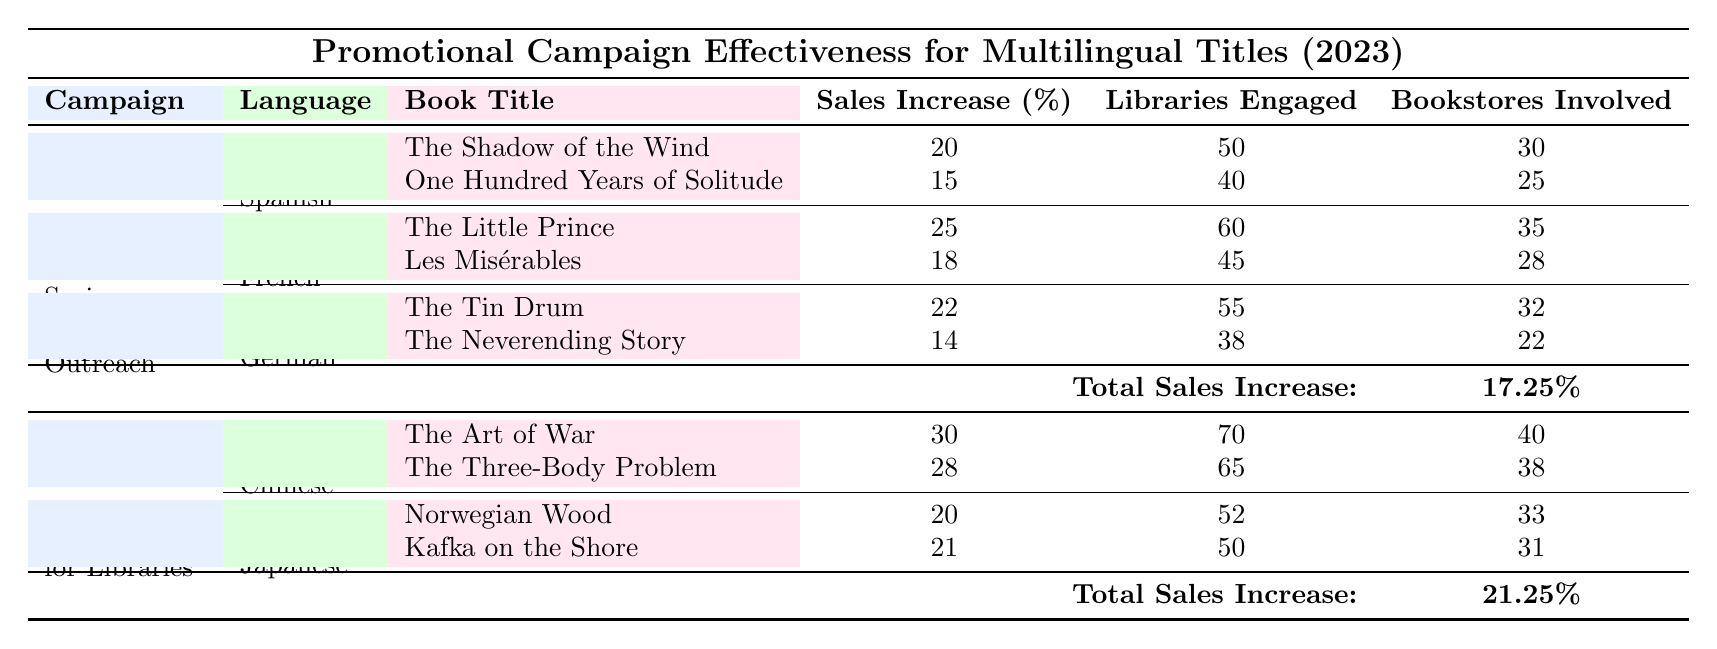What is the total sales increase for the "Spring Multilingual Outreach" campaign? The table states that the total sales increase for the "Spring Multilingual Outreach" campaign is listed under the campaign details as 17.25%.
Answer: 17.25% Which language had the highest sales increase per title during the "Global Reads for Libraries" campaign? The table shows that the "Chinese" language titles had sales increases of 30% for "The Art of War" and 28% for "The Three-Body Problem," better than the "Japanese" titles which had increases of 20% and 21%. Hence, "Chinese" has the highest sales increase per title.
Answer: Chinese Did the campaign "Global Reads for Libraries" engage more libraries than the "Spring Multilingual Outreach" campaign? The total libraries engaged in the "Global Reads for Libraries" campaign adds to 135 (70 + 65), while the "Spring Multilingual Outreach" engaged 133 libraries (50 + 40 + 55). Since 135 is greater than 133, the "Global Reads for Libraries" engaged more libraries.
Answer: Yes What is the average sales increase of the book titles in the Spanish language for the "Spring Multilingual Outreach" campaign? The sales increases for the Spanish titles are 20% and 15%. To find the average: (20 + 15) / 2 = 17.5%.
Answer: 17.5% Is the "Bookstores Involved" for "Les Misérables" greater than that for "The Neverending Story"? The "Bookstores Involved" for "Les Misérables" is 28, while for "The Neverending Story," it is 22. Since 28 is greater than 22, the statement is true.
Answer: Yes How many more libraries were engaged by the French titles than by the German titles in the "Spring Multilingual Outreach" campaign? The French titles engaged 105 libraries (60 + 45) whereas the German titles engaged 93 libraries (55 + 38). The difference is 105 - 93 = 12, indicating that French titles engaged 12 more libraries.
Answer: 12 Which French book title had the lowest sales increase? The sales increases for French titles are 25% for "The Little Prince" and 18% for "Les Misérables." Since 18% is less than 25%, "Les Misérables" had the lowest sales increase among the French titles.
Answer: Les Misérables What is the total sales increase across all campaigns? To find the total sales increase across all campaigns, we sum the total sales increases: 17.25% (Spring Multilingual Outreach) + 21.25% (Global Reads for Libraries) = 38.5%.
Answer: 38.5% 